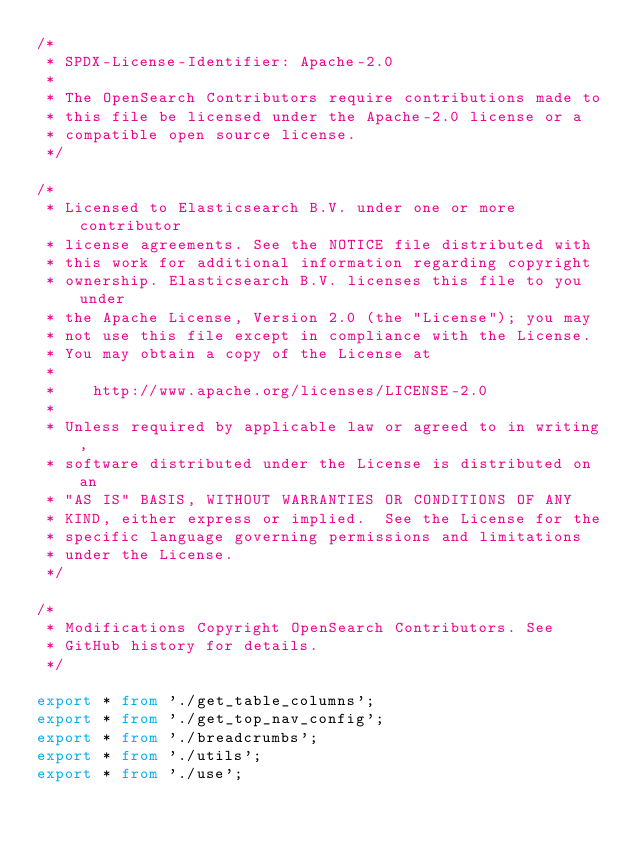<code> <loc_0><loc_0><loc_500><loc_500><_TypeScript_>/*
 * SPDX-License-Identifier: Apache-2.0
 *
 * The OpenSearch Contributors require contributions made to
 * this file be licensed under the Apache-2.0 license or a
 * compatible open source license.
 */

/*
 * Licensed to Elasticsearch B.V. under one or more contributor
 * license agreements. See the NOTICE file distributed with
 * this work for additional information regarding copyright
 * ownership. Elasticsearch B.V. licenses this file to you under
 * the Apache License, Version 2.0 (the "License"); you may
 * not use this file except in compliance with the License.
 * You may obtain a copy of the License at
 *
 *    http://www.apache.org/licenses/LICENSE-2.0
 *
 * Unless required by applicable law or agreed to in writing,
 * software distributed under the License is distributed on an
 * "AS IS" BASIS, WITHOUT WARRANTIES OR CONDITIONS OF ANY
 * KIND, either express or implied.  See the License for the
 * specific language governing permissions and limitations
 * under the License.
 */

/*
 * Modifications Copyright OpenSearch Contributors. See
 * GitHub history for details.
 */

export * from './get_table_columns';
export * from './get_top_nav_config';
export * from './breadcrumbs';
export * from './utils';
export * from './use';
</code> 